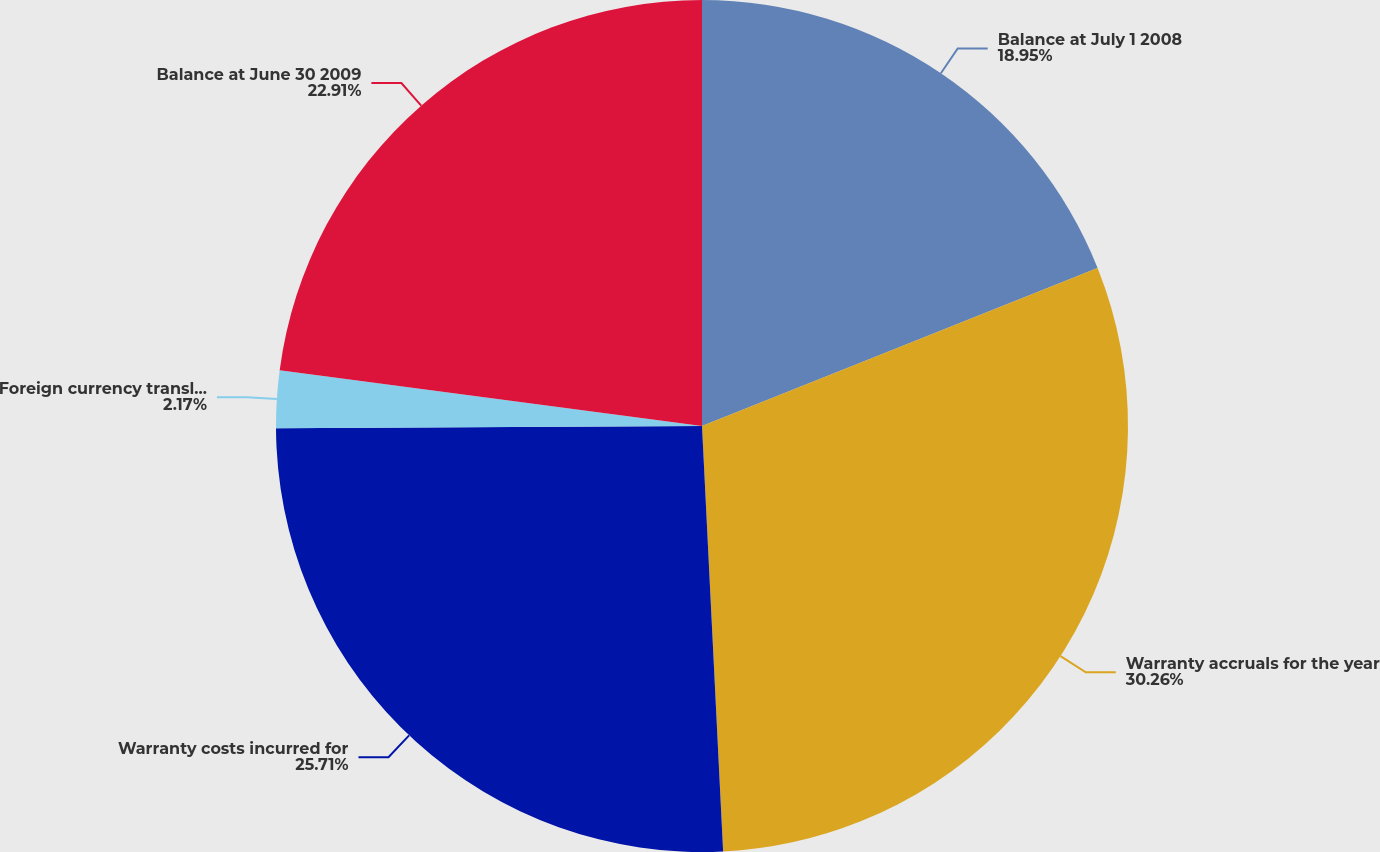Convert chart. <chart><loc_0><loc_0><loc_500><loc_500><pie_chart><fcel>Balance at July 1 2008<fcel>Warranty accruals for the year<fcel>Warranty costs incurred for<fcel>Foreign currency translation<fcel>Balance at June 30 2009<nl><fcel>18.95%<fcel>30.26%<fcel>25.71%<fcel>2.17%<fcel>22.91%<nl></chart> 